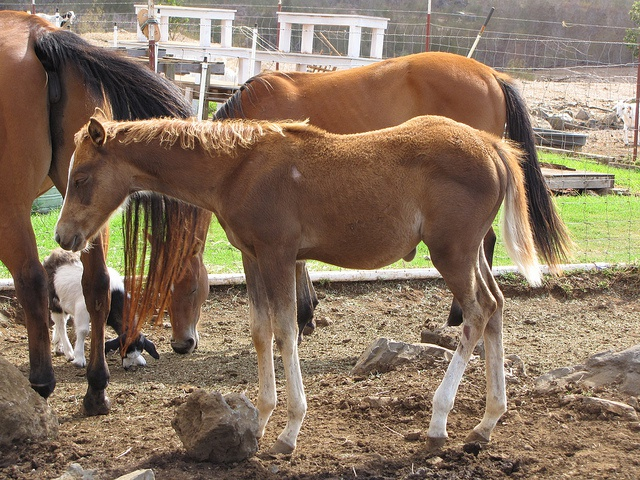Describe the objects in this image and their specific colors. I can see horse in gray and maroon tones, horse in gray, black, and maroon tones, and horse in gray, brown, and black tones in this image. 